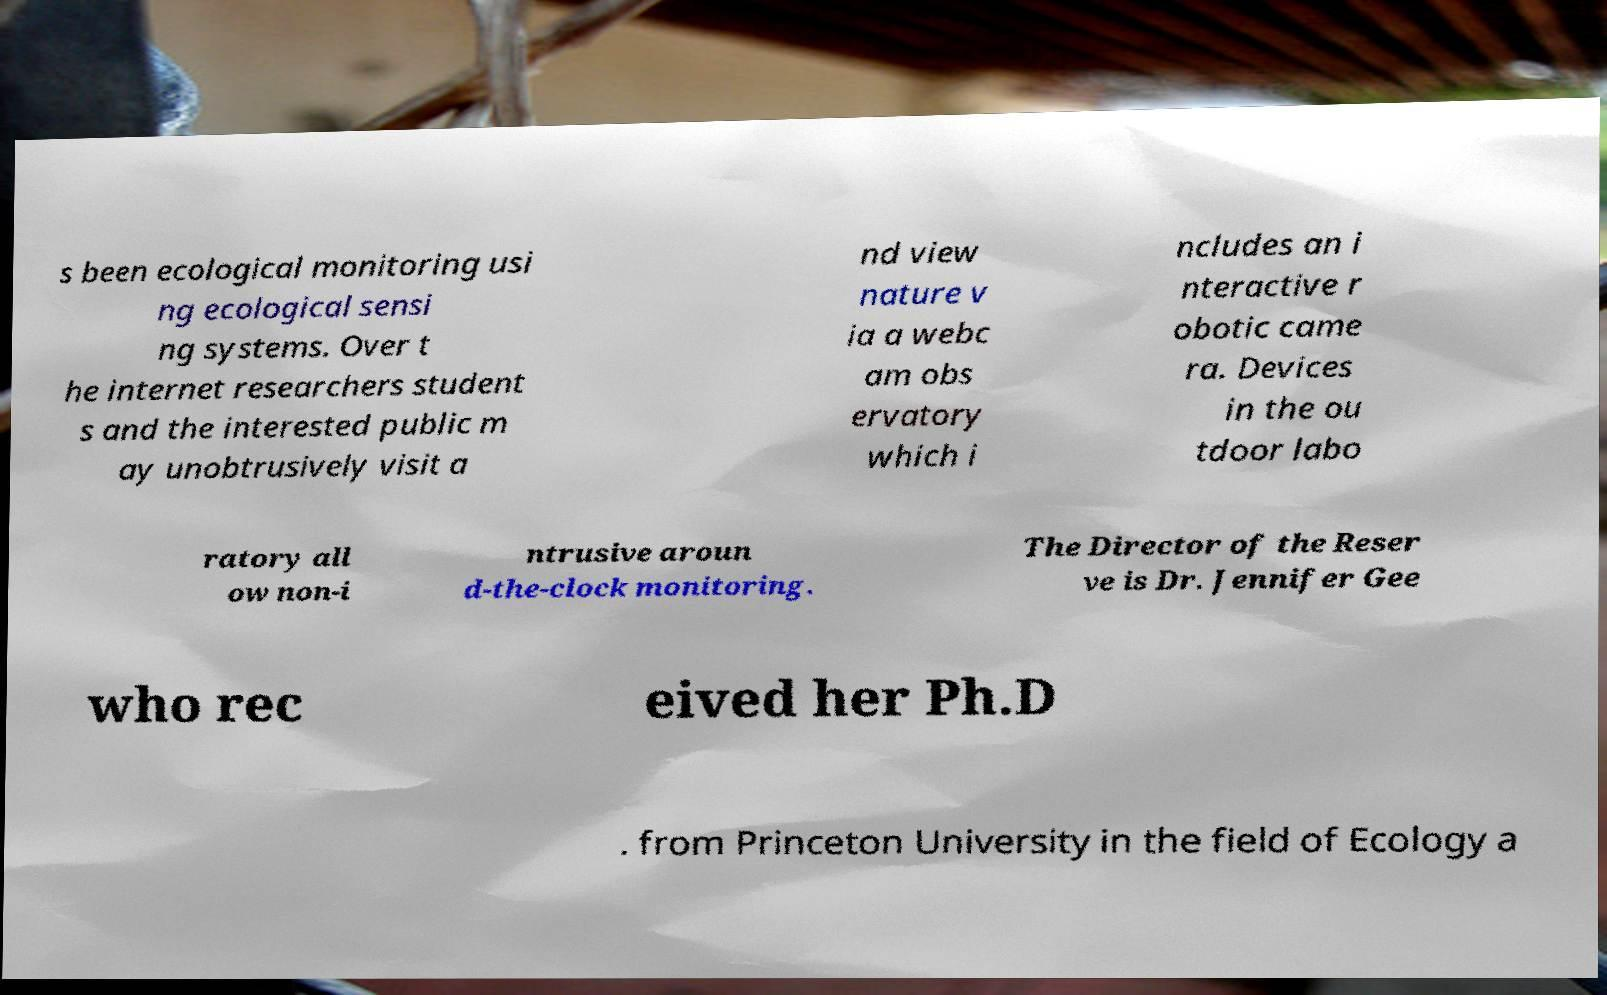There's text embedded in this image that I need extracted. Can you transcribe it verbatim? s been ecological monitoring usi ng ecological sensi ng systems. Over t he internet researchers student s and the interested public m ay unobtrusively visit a nd view nature v ia a webc am obs ervatory which i ncludes an i nteractive r obotic came ra. Devices in the ou tdoor labo ratory all ow non-i ntrusive aroun d-the-clock monitoring. The Director of the Reser ve is Dr. Jennifer Gee who rec eived her Ph.D . from Princeton University in the field of Ecology a 